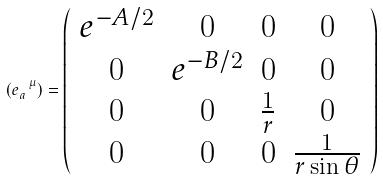Convert formula to latex. <formula><loc_0><loc_0><loc_500><loc_500>( e _ { a } ^ { \text { \ \ } \mu } ) = \left ( \begin{array} { c c c c } e ^ { - A / 2 } & 0 & 0 & 0 \\ 0 & e ^ { - B / 2 } & 0 & 0 \\ 0 & 0 & \frac { 1 } { r } & 0 \\ 0 & 0 & 0 & \frac { 1 } { r \sin \theta } \end{array} \right )</formula> 